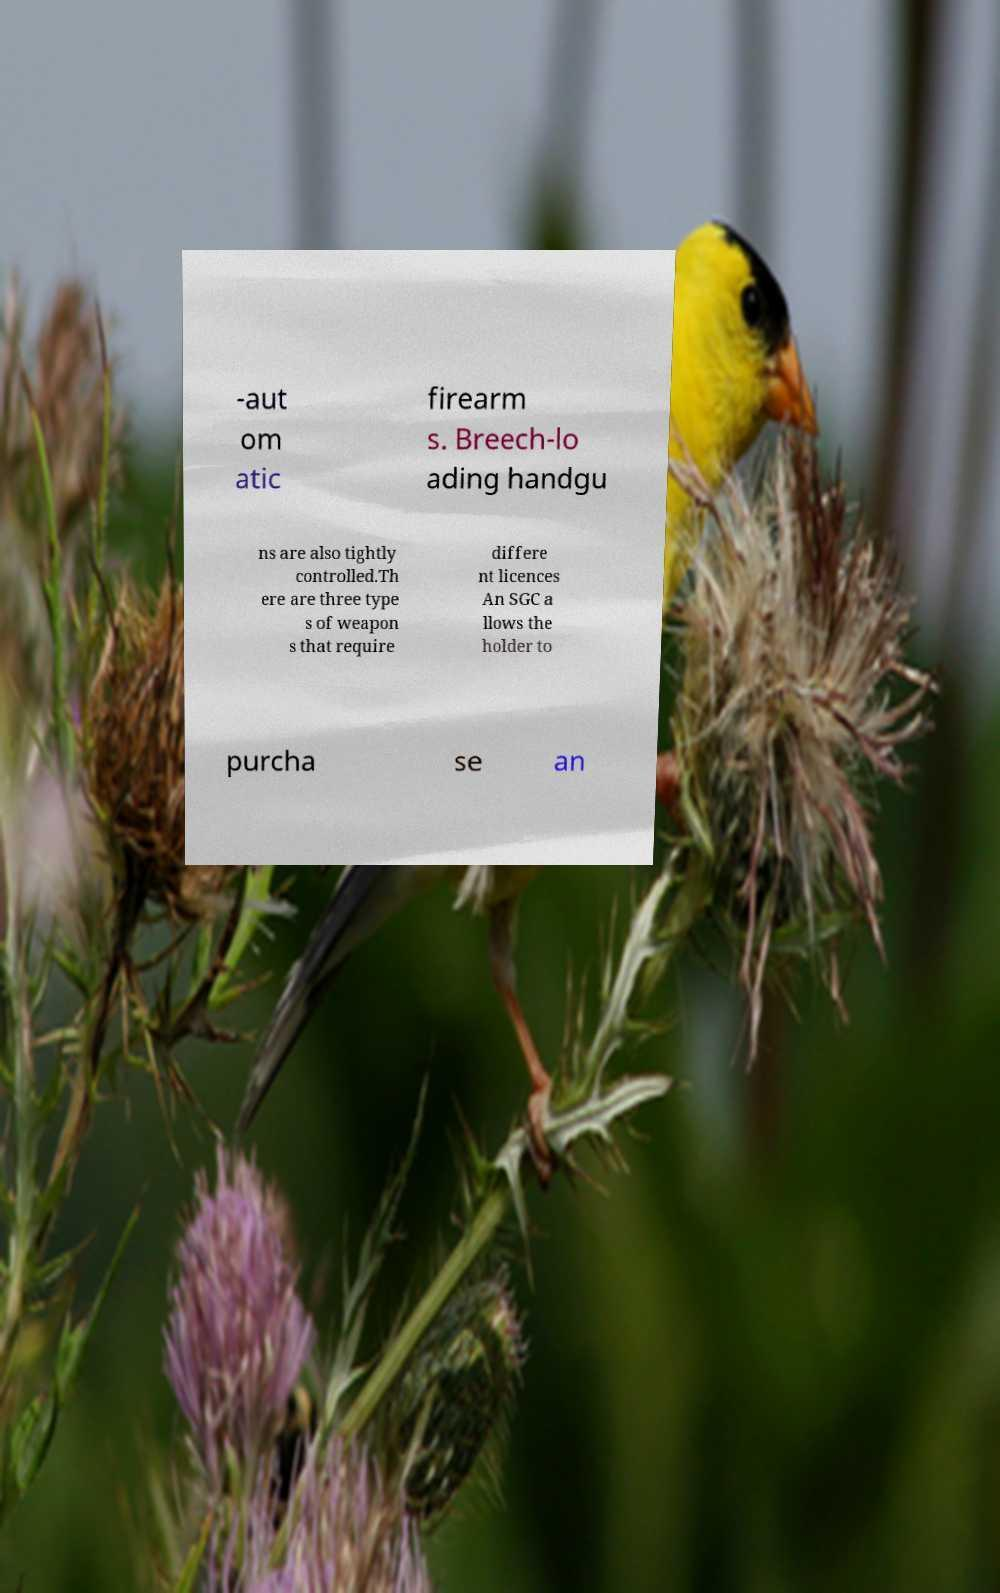Please read and relay the text visible in this image. What does it say? -aut om atic firearm s. Breech-lo ading handgu ns are also tightly controlled.Th ere are three type s of weapon s that require differe nt licences An SGC a llows the holder to purcha se an 